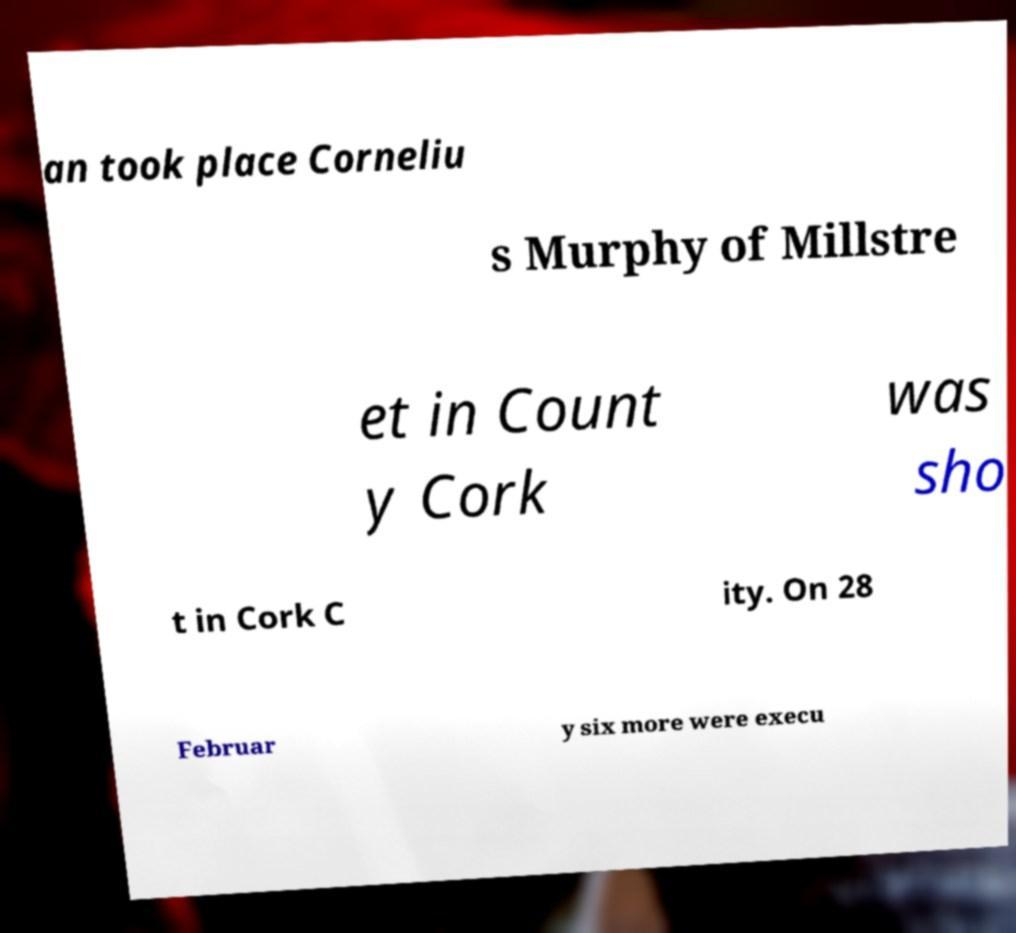Could you assist in decoding the text presented in this image and type it out clearly? an took place Corneliu s Murphy of Millstre et in Count y Cork was sho t in Cork C ity. On 28 Februar y six more were execu 